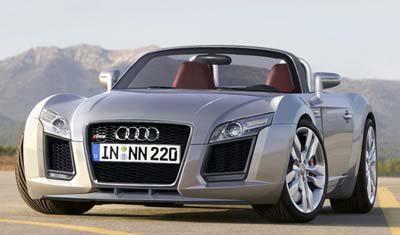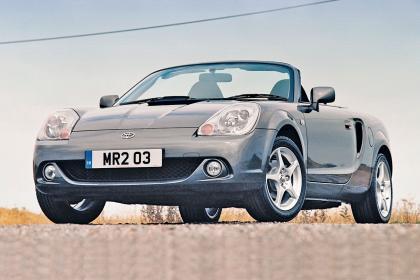The first image is the image on the left, the second image is the image on the right. Analyze the images presented: Is the assertion "A red sportscar and a light colored sportscar are both convertibles with chrome wheels, black interiors, and logo at center front." valid? Answer yes or no. No. The first image is the image on the left, the second image is the image on the right. Assess this claim about the two images: "An image shows one red convertible with top down, turned at a leftward-facing angle.". Correct or not? Answer yes or no. No. 